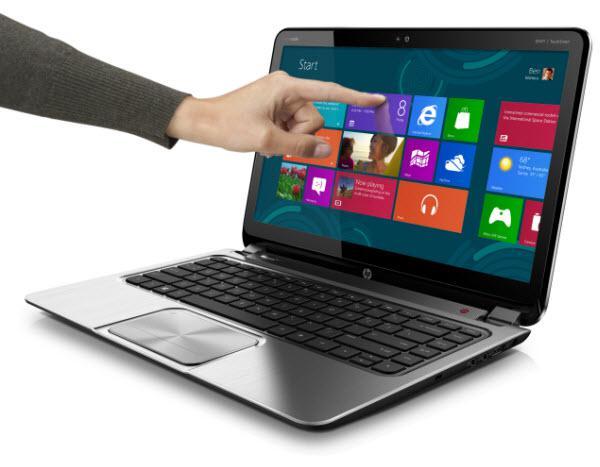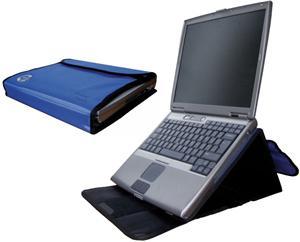The first image is the image on the left, the second image is the image on the right. Assess this claim about the two images: "An image shows at least five laptops.". Correct or not? Answer yes or no. No. The first image is the image on the left, the second image is the image on the right. For the images shown, is this caption "At least five laptop computer styles are arrayed in one image." true? Answer yes or no. No. 